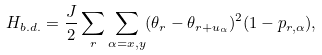<formula> <loc_0><loc_0><loc_500><loc_500>H _ { b . d . } = \frac { J } { 2 } \sum _ { r } \sum _ { \alpha = x , y } ( \theta _ { r } - \theta _ { { r } + { u } _ { \alpha } } ) ^ { 2 } ( 1 - p _ { { r } , \alpha } ) ,</formula> 